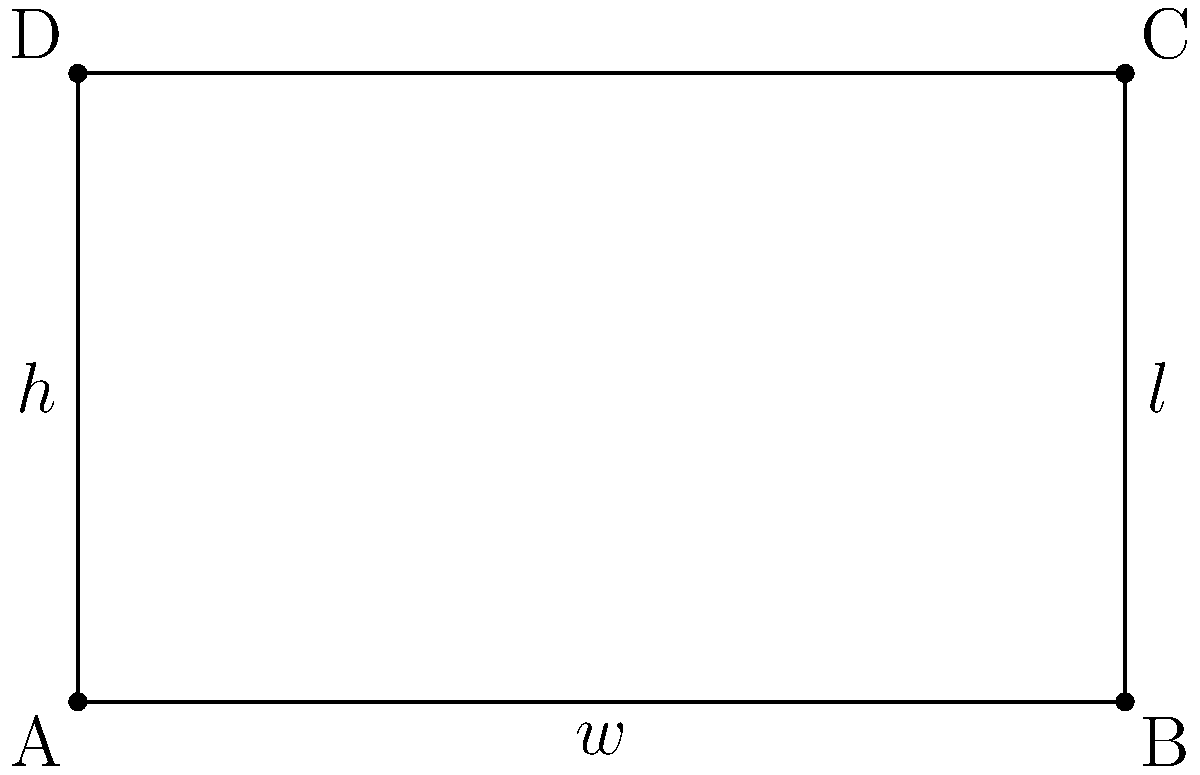As a jazz musician planning to convert a heritage building in Perth into a music practice space, you need to determine the optimal dimensions for a rectangular room to maximize acoustic quality. The room has a fixed height of 3 meters and a total surface area of 150 square meters (including the floor and ceiling). Find the width and length of the room that will minimize the total edge length, which is crucial for reducing sound reflections and improving acoustic performance. Let's approach this step-by-step:

1) Let $w$ be the width, $l$ be the length, and $h$ be the height of the room.

2) Given: $h = 3$ meters, and total surface area = 150 sq meters.

3) The surface area equation:
   $2(wl + wh + lh) = 150$

4) Substituting $h = 3$:
   $2(wl + 3w + 3l) = 150$
   $2wl + 6w + 6l = 150$
   $wl + 3w + 3l = 75$

5) The total edge length to be minimized is:
   $E = 4w + 4l + 4h = 4w + 4l + 12$

6) We need to express $l$ in terms of $w$. From step 4:
   $l(w + 3) = 75 - 3w$
   $l = \frac{75 - 3w}{w + 3}$

7) Now, substitute this into the edge length equation:
   $E = 4w + 4(\frac{75 - 3w}{w + 3}) + 12$

8) To find the minimum, differentiate $E$ with respect to $w$ and set it to zero:
   $\frac{dE}{dw} = 4 - 4(\frac{75 + 9}{(w + 3)^2}) = 0$

9) Solving this equation:
   $4 = \frac{336}{(w + 3)^2}$
   $(w + 3)^2 = 84$
   $w + 3 = \sqrt{84}$
   $w = \sqrt{84} - 3 \approx 6.17$ meters

10) Calculate $l$ using the result from step 6:
    $l = \frac{75 - 3(6.17)}{6.17 + 3} \approx 6.17$ meters

Therefore, the optimal dimensions are approximately 6.17 meters for both width and length.
Answer: Width ≈ 6.17 m, Length ≈ 6.17 m 